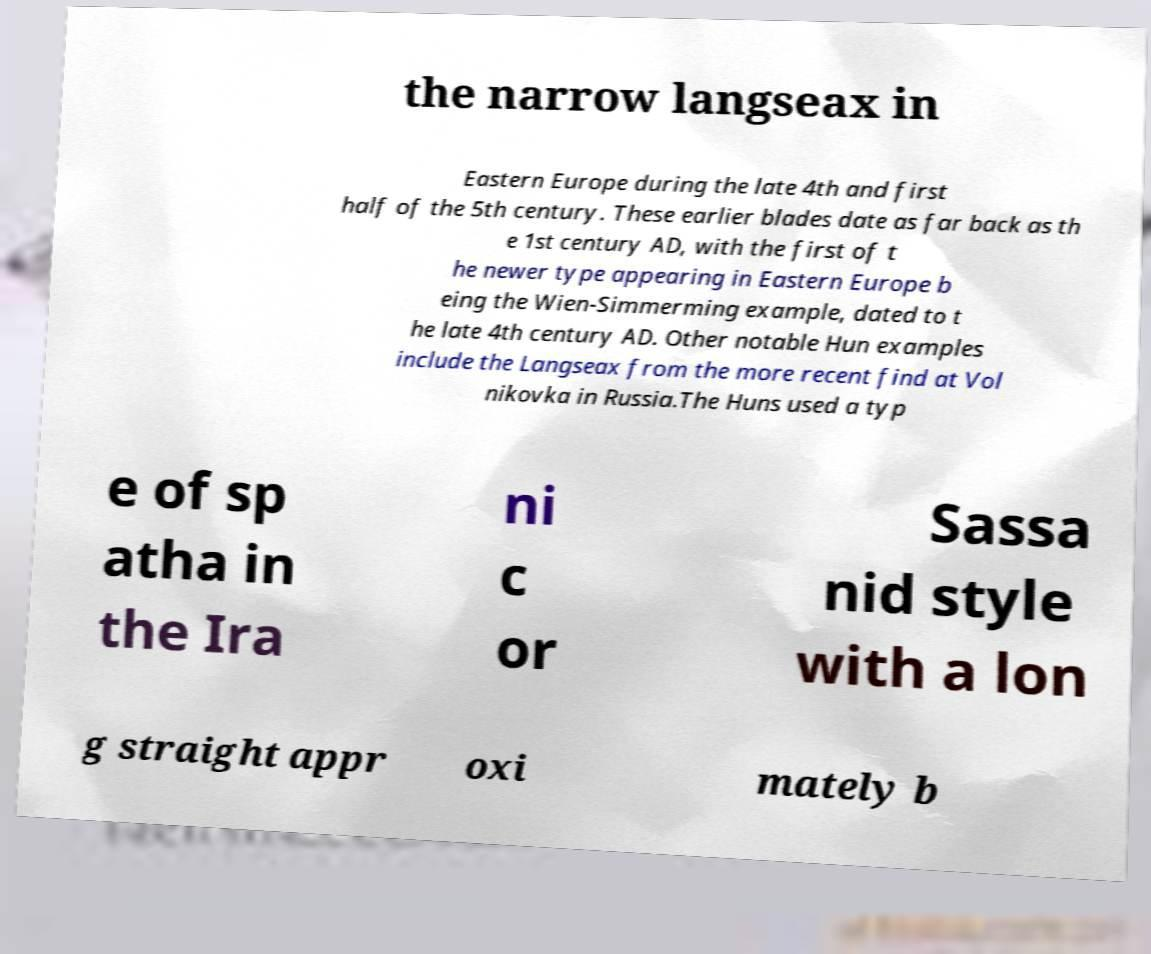Could you extract and type out the text from this image? the narrow langseax in Eastern Europe during the late 4th and first half of the 5th century. These earlier blades date as far back as th e 1st century AD, with the first of t he newer type appearing in Eastern Europe b eing the Wien-Simmerming example, dated to t he late 4th century AD. Other notable Hun examples include the Langseax from the more recent find at Vol nikovka in Russia.The Huns used a typ e of sp atha in the Ira ni c or Sassa nid style with a lon g straight appr oxi mately b 